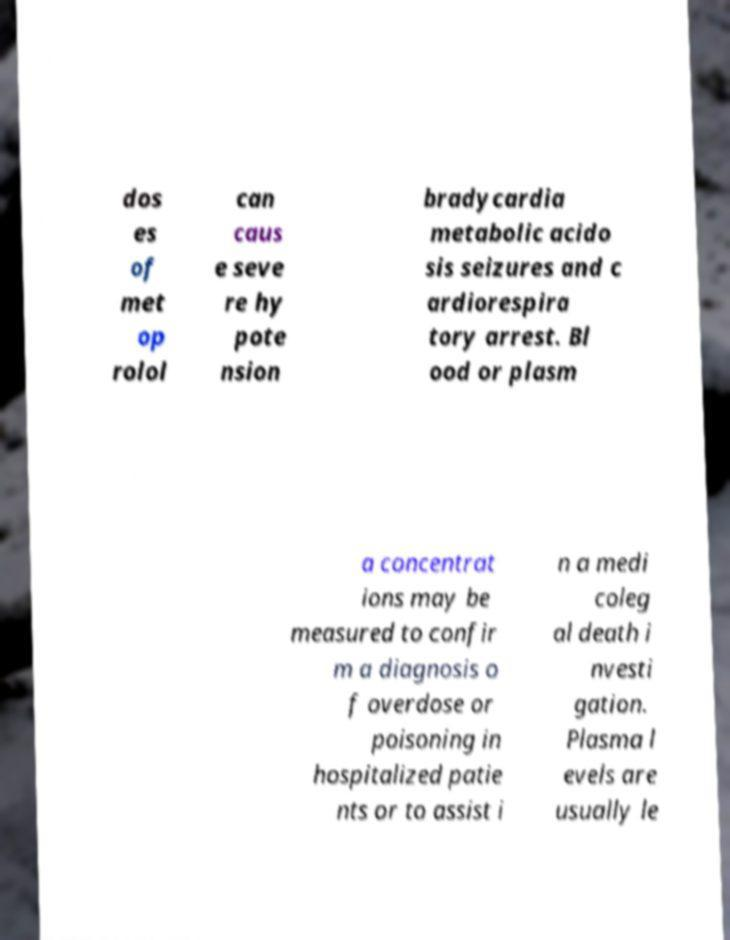Could you extract and type out the text from this image? dos es of met op rolol can caus e seve re hy pote nsion bradycardia metabolic acido sis seizures and c ardiorespira tory arrest. Bl ood or plasm a concentrat ions may be measured to confir m a diagnosis o f overdose or poisoning in hospitalized patie nts or to assist i n a medi coleg al death i nvesti gation. Plasma l evels are usually le 